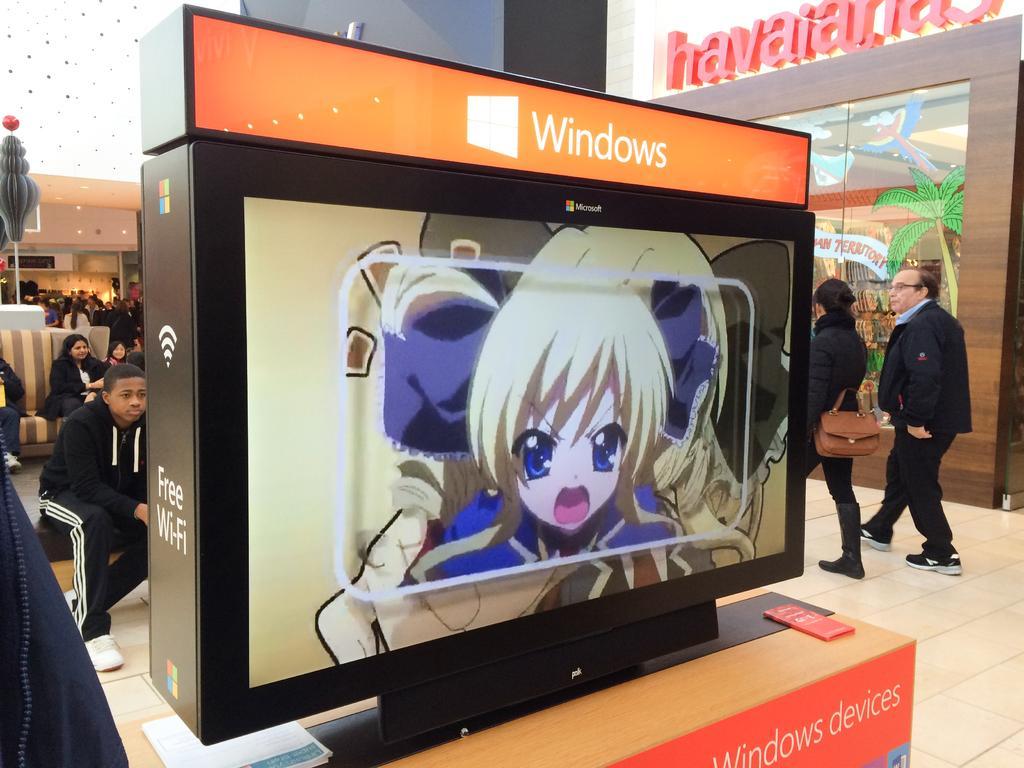Can you describe this image briefly? In this image in the front there is a monitor and on the monitor there are some text written on it and there is the images of the cartoon displaying on the monitor. In the background there are persons sitting and walking. On the right side there is a glass and behind the glass there is a tree and on the top of the glass there is some text written on it. In the background there are persons and there is a wall and there is a pole. 